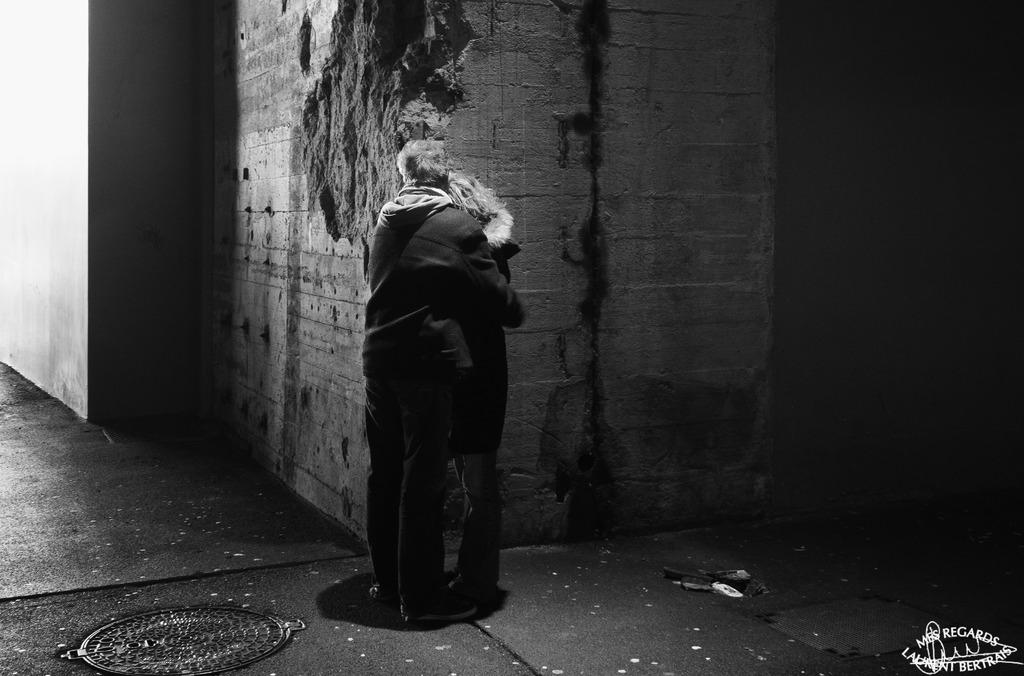What is happening in the image? There are persons standing in the image. Where are the persons standing? The persons are standing on the floor. What can be seen in the background of the image? There are walls visible in the background of the image. What type of apparatus is being used by the persons in the image? There is no apparatus visible in the image; the persons are simply standing on the floor. What kind of wine is being served in the image? There is no wine present in the image. 